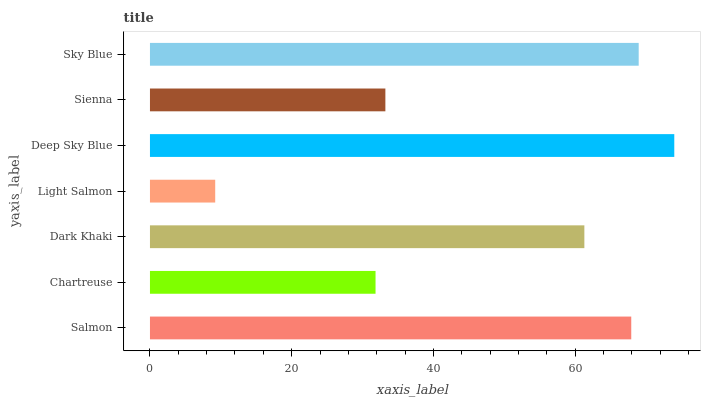Is Light Salmon the minimum?
Answer yes or no. Yes. Is Deep Sky Blue the maximum?
Answer yes or no. Yes. Is Chartreuse the minimum?
Answer yes or no. No. Is Chartreuse the maximum?
Answer yes or no. No. Is Salmon greater than Chartreuse?
Answer yes or no. Yes. Is Chartreuse less than Salmon?
Answer yes or no. Yes. Is Chartreuse greater than Salmon?
Answer yes or no. No. Is Salmon less than Chartreuse?
Answer yes or no. No. Is Dark Khaki the high median?
Answer yes or no. Yes. Is Dark Khaki the low median?
Answer yes or no. Yes. Is Sienna the high median?
Answer yes or no. No. Is Sienna the low median?
Answer yes or no. No. 